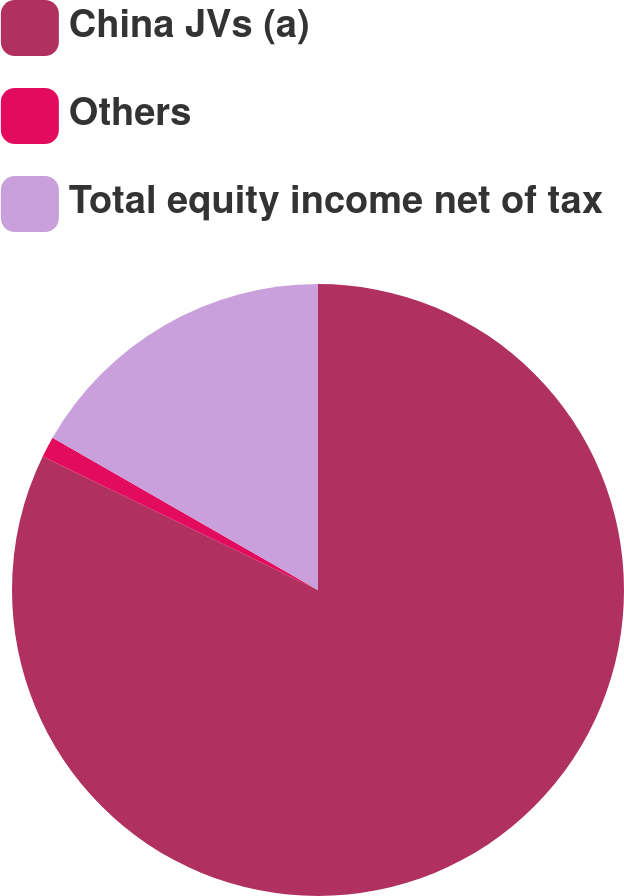Convert chart. <chart><loc_0><loc_0><loc_500><loc_500><pie_chart><fcel>China JVs (a)<fcel>Others<fcel>Total equity income net of tax<nl><fcel>82.19%<fcel>1.1%<fcel>16.71%<nl></chart> 